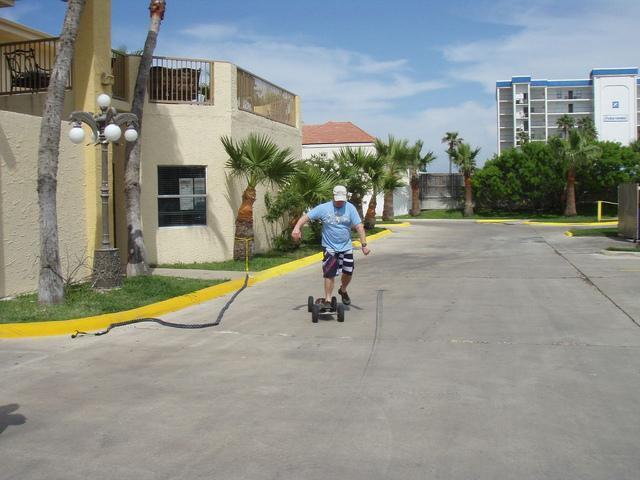How many lights are on the streetlight?
Give a very brief answer. 4. 